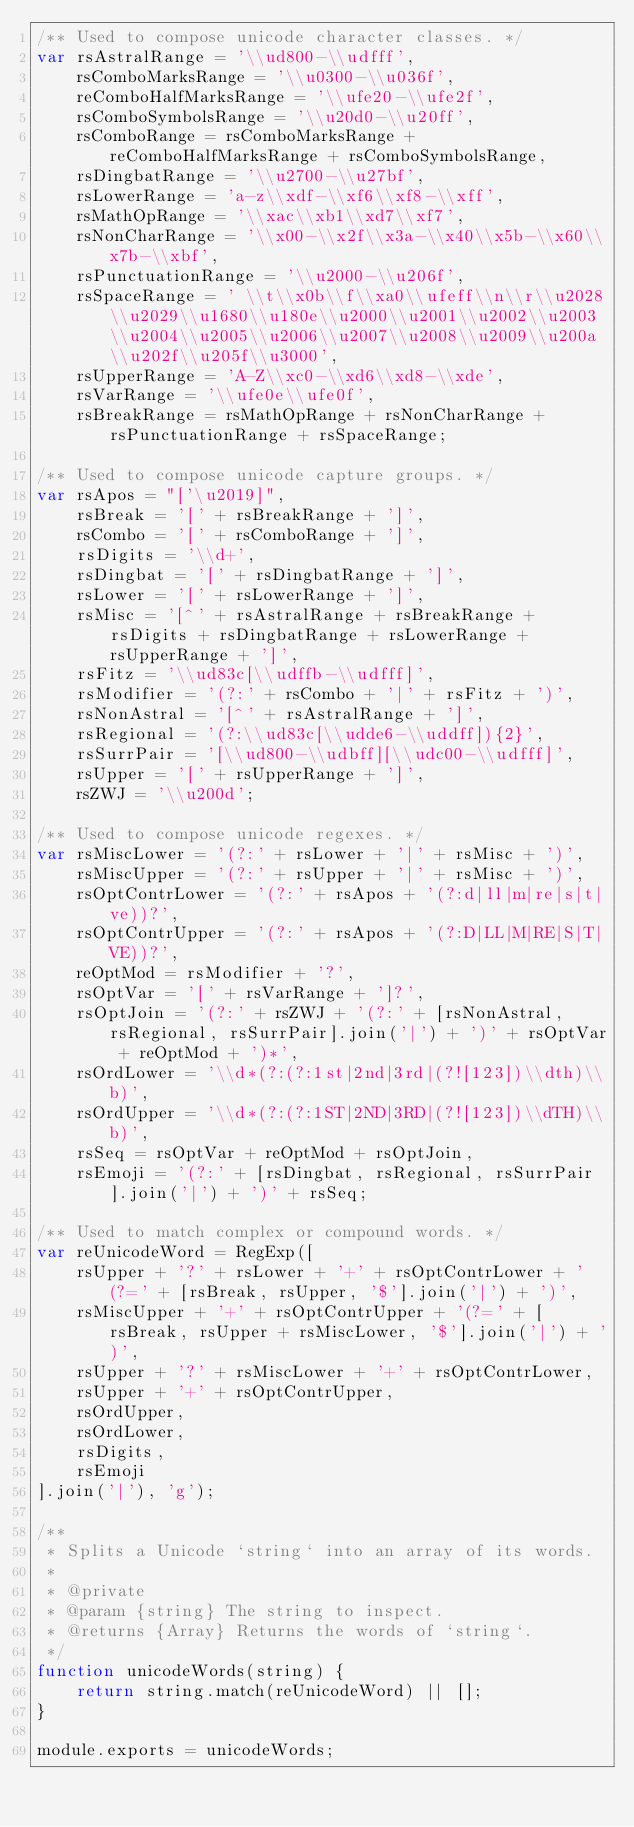Convert code to text. <code><loc_0><loc_0><loc_500><loc_500><_JavaScript_>/** Used to compose unicode character classes. */
var rsAstralRange = '\\ud800-\\udfff',
    rsComboMarksRange = '\\u0300-\\u036f',
    reComboHalfMarksRange = '\\ufe20-\\ufe2f',
    rsComboSymbolsRange = '\\u20d0-\\u20ff',
    rsComboRange = rsComboMarksRange + reComboHalfMarksRange + rsComboSymbolsRange,
    rsDingbatRange = '\\u2700-\\u27bf',
    rsLowerRange = 'a-z\\xdf-\\xf6\\xf8-\\xff',
    rsMathOpRange = '\\xac\\xb1\\xd7\\xf7',
    rsNonCharRange = '\\x00-\\x2f\\x3a-\\x40\\x5b-\\x60\\x7b-\\xbf',
    rsPunctuationRange = '\\u2000-\\u206f',
    rsSpaceRange = ' \\t\\x0b\\f\\xa0\\ufeff\\n\\r\\u2028\\u2029\\u1680\\u180e\\u2000\\u2001\\u2002\\u2003\\u2004\\u2005\\u2006\\u2007\\u2008\\u2009\\u200a\\u202f\\u205f\\u3000',
    rsUpperRange = 'A-Z\\xc0-\\xd6\\xd8-\\xde',
    rsVarRange = '\\ufe0e\\ufe0f',
    rsBreakRange = rsMathOpRange + rsNonCharRange + rsPunctuationRange + rsSpaceRange;

/** Used to compose unicode capture groups. */
var rsApos = "['\u2019]",
    rsBreak = '[' + rsBreakRange + ']',
    rsCombo = '[' + rsComboRange + ']',
    rsDigits = '\\d+',
    rsDingbat = '[' + rsDingbatRange + ']',
    rsLower = '[' + rsLowerRange + ']',
    rsMisc = '[^' + rsAstralRange + rsBreakRange + rsDigits + rsDingbatRange + rsLowerRange + rsUpperRange + ']',
    rsFitz = '\\ud83c[\\udffb-\\udfff]',
    rsModifier = '(?:' + rsCombo + '|' + rsFitz + ')',
    rsNonAstral = '[^' + rsAstralRange + ']',
    rsRegional = '(?:\\ud83c[\\udde6-\\uddff]){2}',
    rsSurrPair = '[\\ud800-\\udbff][\\udc00-\\udfff]',
    rsUpper = '[' + rsUpperRange + ']',
    rsZWJ = '\\u200d';

/** Used to compose unicode regexes. */
var rsMiscLower = '(?:' + rsLower + '|' + rsMisc + ')',
    rsMiscUpper = '(?:' + rsUpper + '|' + rsMisc + ')',
    rsOptContrLower = '(?:' + rsApos + '(?:d|ll|m|re|s|t|ve))?',
    rsOptContrUpper = '(?:' + rsApos + '(?:D|LL|M|RE|S|T|VE))?',
    reOptMod = rsModifier + '?',
    rsOptVar = '[' + rsVarRange + ']?',
    rsOptJoin = '(?:' + rsZWJ + '(?:' + [rsNonAstral, rsRegional, rsSurrPair].join('|') + ')' + rsOptVar + reOptMod + ')*',
    rsOrdLower = '\\d*(?:(?:1st|2nd|3rd|(?![123])\\dth)\\b)',
    rsOrdUpper = '\\d*(?:(?:1ST|2ND|3RD|(?![123])\\dTH)\\b)',
    rsSeq = rsOptVar + reOptMod + rsOptJoin,
    rsEmoji = '(?:' + [rsDingbat, rsRegional, rsSurrPair].join('|') + ')' + rsSeq;

/** Used to match complex or compound words. */
var reUnicodeWord = RegExp([
    rsUpper + '?' + rsLower + '+' + rsOptContrLower + '(?=' + [rsBreak, rsUpper, '$'].join('|') + ')',
    rsMiscUpper + '+' + rsOptContrUpper + '(?=' + [rsBreak, rsUpper + rsMiscLower, '$'].join('|') + ')',
    rsUpper + '?' + rsMiscLower + '+' + rsOptContrLower,
    rsUpper + '+' + rsOptContrUpper,
    rsOrdUpper,
    rsOrdLower,
    rsDigits,
    rsEmoji
].join('|'), 'g');

/**
 * Splits a Unicode `string` into an array of its words.
 *
 * @private
 * @param {string} The string to inspect.
 * @returns {Array} Returns the words of `string`.
 */
function unicodeWords(string) {
    return string.match(reUnicodeWord) || [];
}

module.exports = unicodeWords;
</code> 